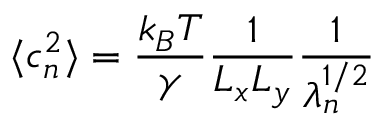Convert formula to latex. <formula><loc_0><loc_0><loc_500><loc_500>\langle c _ { n } ^ { 2 } \rangle = \frac { k _ { B } T } { \gamma } \frac { 1 } { L _ { x } L _ { y } } \frac { 1 } { \lambda _ { n } ^ { 1 / 2 } }</formula> 